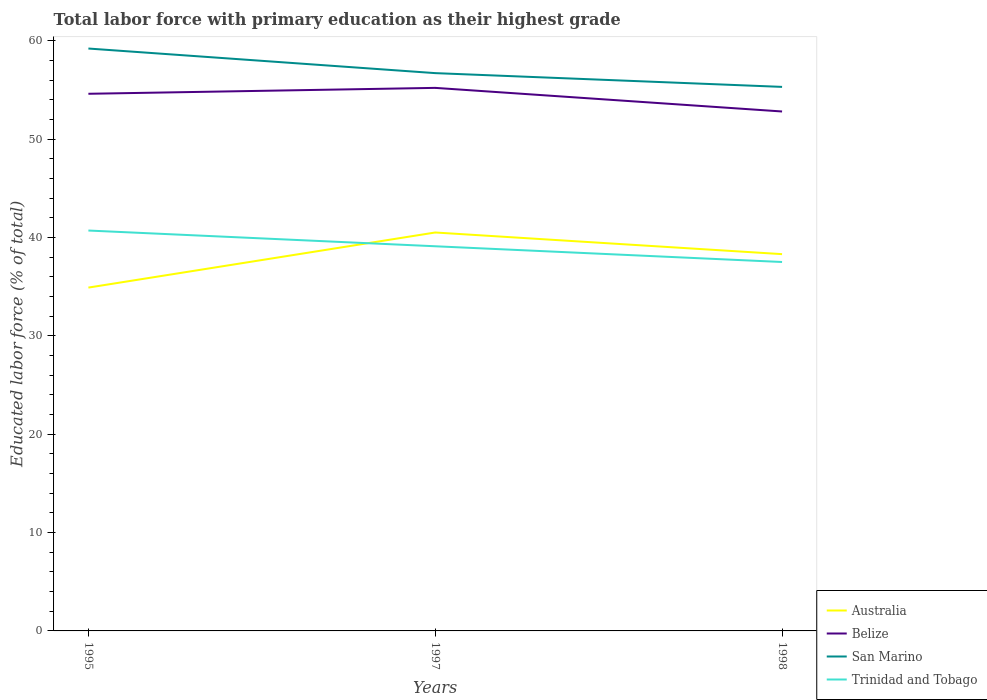Does the line corresponding to San Marino intersect with the line corresponding to Australia?
Provide a short and direct response. No. Across all years, what is the maximum percentage of total labor force with primary education in Trinidad and Tobago?
Offer a terse response. 37.5. What is the total percentage of total labor force with primary education in San Marino in the graph?
Your response must be concise. 1.4. What is the difference between the highest and the second highest percentage of total labor force with primary education in San Marino?
Keep it short and to the point. 3.9. What is the difference between the highest and the lowest percentage of total labor force with primary education in Belize?
Offer a very short reply. 2. How many years are there in the graph?
Keep it short and to the point. 3. What is the difference between two consecutive major ticks on the Y-axis?
Ensure brevity in your answer.  10. Does the graph contain grids?
Your response must be concise. No. Where does the legend appear in the graph?
Provide a short and direct response. Bottom right. How are the legend labels stacked?
Your answer should be compact. Vertical. What is the title of the graph?
Provide a succinct answer. Total labor force with primary education as their highest grade. Does "Romania" appear as one of the legend labels in the graph?
Provide a succinct answer. No. What is the label or title of the Y-axis?
Make the answer very short. Educated labor force (% of total). What is the Educated labor force (% of total) in Australia in 1995?
Provide a succinct answer. 34.9. What is the Educated labor force (% of total) of Belize in 1995?
Offer a terse response. 54.6. What is the Educated labor force (% of total) of San Marino in 1995?
Your answer should be compact. 59.2. What is the Educated labor force (% of total) in Trinidad and Tobago in 1995?
Keep it short and to the point. 40.7. What is the Educated labor force (% of total) in Australia in 1997?
Keep it short and to the point. 40.5. What is the Educated labor force (% of total) of Belize in 1997?
Provide a succinct answer. 55.2. What is the Educated labor force (% of total) in San Marino in 1997?
Make the answer very short. 56.7. What is the Educated labor force (% of total) in Trinidad and Tobago in 1997?
Offer a terse response. 39.1. What is the Educated labor force (% of total) of Australia in 1998?
Offer a terse response. 38.3. What is the Educated labor force (% of total) of Belize in 1998?
Ensure brevity in your answer.  52.8. What is the Educated labor force (% of total) in San Marino in 1998?
Offer a terse response. 55.3. What is the Educated labor force (% of total) of Trinidad and Tobago in 1998?
Offer a very short reply. 37.5. Across all years, what is the maximum Educated labor force (% of total) in Australia?
Ensure brevity in your answer.  40.5. Across all years, what is the maximum Educated labor force (% of total) in Belize?
Give a very brief answer. 55.2. Across all years, what is the maximum Educated labor force (% of total) in San Marino?
Give a very brief answer. 59.2. Across all years, what is the maximum Educated labor force (% of total) of Trinidad and Tobago?
Offer a very short reply. 40.7. Across all years, what is the minimum Educated labor force (% of total) in Australia?
Provide a short and direct response. 34.9. Across all years, what is the minimum Educated labor force (% of total) in Belize?
Make the answer very short. 52.8. Across all years, what is the minimum Educated labor force (% of total) in San Marino?
Provide a short and direct response. 55.3. Across all years, what is the minimum Educated labor force (% of total) in Trinidad and Tobago?
Keep it short and to the point. 37.5. What is the total Educated labor force (% of total) in Australia in the graph?
Make the answer very short. 113.7. What is the total Educated labor force (% of total) in Belize in the graph?
Your response must be concise. 162.6. What is the total Educated labor force (% of total) of San Marino in the graph?
Your answer should be very brief. 171.2. What is the total Educated labor force (% of total) in Trinidad and Tobago in the graph?
Provide a succinct answer. 117.3. What is the difference between the Educated labor force (% of total) in Belize in 1995 and that in 1997?
Offer a terse response. -0.6. What is the difference between the Educated labor force (% of total) of San Marino in 1995 and that in 1997?
Your answer should be compact. 2.5. What is the difference between the Educated labor force (% of total) in Australia in 1995 and that in 1998?
Provide a succinct answer. -3.4. What is the difference between the Educated labor force (% of total) of Belize in 1995 and that in 1998?
Your answer should be compact. 1.8. What is the difference between the Educated labor force (% of total) of Trinidad and Tobago in 1995 and that in 1998?
Make the answer very short. 3.2. What is the difference between the Educated labor force (% of total) in Australia in 1997 and that in 1998?
Give a very brief answer. 2.2. What is the difference between the Educated labor force (% of total) in San Marino in 1997 and that in 1998?
Make the answer very short. 1.4. What is the difference between the Educated labor force (% of total) of Trinidad and Tobago in 1997 and that in 1998?
Keep it short and to the point. 1.6. What is the difference between the Educated labor force (% of total) of Australia in 1995 and the Educated labor force (% of total) of Belize in 1997?
Provide a succinct answer. -20.3. What is the difference between the Educated labor force (% of total) in Australia in 1995 and the Educated labor force (% of total) in San Marino in 1997?
Your response must be concise. -21.8. What is the difference between the Educated labor force (% of total) of Australia in 1995 and the Educated labor force (% of total) of Trinidad and Tobago in 1997?
Give a very brief answer. -4.2. What is the difference between the Educated labor force (% of total) of Belize in 1995 and the Educated labor force (% of total) of Trinidad and Tobago in 1997?
Your response must be concise. 15.5. What is the difference between the Educated labor force (% of total) in San Marino in 1995 and the Educated labor force (% of total) in Trinidad and Tobago in 1997?
Provide a short and direct response. 20.1. What is the difference between the Educated labor force (% of total) in Australia in 1995 and the Educated labor force (% of total) in Belize in 1998?
Offer a terse response. -17.9. What is the difference between the Educated labor force (% of total) of Australia in 1995 and the Educated labor force (% of total) of San Marino in 1998?
Provide a succinct answer. -20.4. What is the difference between the Educated labor force (% of total) in Australia in 1995 and the Educated labor force (% of total) in Trinidad and Tobago in 1998?
Keep it short and to the point. -2.6. What is the difference between the Educated labor force (% of total) of San Marino in 1995 and the Educated labor force (% of total) of Trinidad and Tobago in 1998?
Provide a succinct answer. 21.7. What is the difference between the Educated labor force (% of total) in Australia in 1997 and the Educated labor force (% of total) in Belize in 1998?
Give a very brief answer. -12.3. What is the difference between the Educated labor force (% of total) in Australia in 1997 and the Educated labor force (% of total) in San Marino in 1998?
Give a very brief answer. -14.8. What is the average Educated labor force (% of total) of Australia per year?
Your answer should be very brief. 37.9. What is the average Educated labor force (% of total) in Belize per year?
Offer a very short reply. 54.2. What is the average Educated labor force (% of total) in San Marino per year?
Ensure brevity in your answer.  57.07. What is the average Educated labor force (% of total) in Trinidad and Tobago per year?
Ensure brevity in your answer.  39.1. In the year 1995, what is the difference between the Educated labor force (% of total) in Australia and Educated labor force (% of total) in Belize?
Offer a very short reply. -19.7. In the year 1995, what is the difference between the Educated labor force (% of total) of Australia and Educated labor force (% of total) of San Marino?
Ensure brevity in your answer.  -24.3. In the year 1995, what is the difference between the Educated labor force (% of total) of Australia and Educated labor force (% of total) of Trinidad and Tobago?
Your answer should be compact. -5.8. In the year 1997, what is the difference between the Educated labor force (% of total) of Australia and Educated labor force (% of total) of Belize?
Ensure brevity in your answer.  -14.7. In the year 1997, what is the difference between the Educated labor force (% of total) in Australia and Educated labor force (% of total) in San Marino?
Keep it short and to the point. -16.2. In the year 1997, what is the difference between the Educated labor force (% of total) of Australia and Educated labor force (% of total) of Trinidad and Tobago?
Offer a terse response. 1.4. In the year 1997, what is the difference between the Educated labor force (% of total) of Belize and Educated labor force (% of total) of San Marino?
Make the answer very short. -1.5. In the year 1997, what is the difference between the Educated labor force (% of total) of Belize and Educated labor force (% of total) of Trinidad and Tobago?
Offer a very short reply. 16.1. In the year 1997, what is the difference between the Educated labor force (% of total) of San Marino and Educated labor force (% of total) of Trinidad and Tobago?
Your answer should be very brief. 17.6. In the year 1998, what is the difference between the Educated labor force (% of total) in Australia and Educated labor force (% of total) in Belize?
Your answer should be very brief. -14.5. In the year 1998, what is the difference between the Educated labor force (% of total) of Australia and Educated labor force (% of total) of Trinidad and Tobago?
Offer a terse response. 0.8. In the year 1998, what is the difference between the Educated labor force (% of total) in Belize and Educated labor force (% of total) in San Marino?
Offer a very short reply. -2.5. In the year 1998, what is the difference between the Educated labor force (% of total) of Belize and Educated labor force (% of total) of Trinidad and Tobago?
Ensure brevity in your answer.  15.3. What is the ratio of the Educated labor force (% of total) in Australia in 1995 to that in 1997?
Make the answer very short. 0.86. What is the ratio of the Educated labor force (% of total) in San Marino in 1995 to that in 1997?
Provide a short and direct response. 1.04. What is the ratio of the Educated labor force (% of total) in Trinidad and Tobago in 1995 to that in 1997?
Ensure brevity in your answer.  1.04. What is the ratio of the Educated labor force (% of total) in Australia in 1995 to that in 1998?
Offer a terse response. 0.91. What is the ratio of the Educated labor force (% of total) of Belize in 1995 to that in 1998?
Provide a short and direct response. 1.03. What is the ratio of the Educated labor force (% of total) of San Marino in 1995 to that in 1998?
Your answer should be very brief. 1.07. What is the ratio of the Educated labor force (% of total) of Trinidad and Tobago in 1995 to that in 1998?
Provide a short and direct response. 1.09. What is the ratio of the Educated labor force (% of total) of Australia in 1997 to that in 1998?
Offer a terse response. 1.06. What is the ratio of the Educated labor force (% of total) of Belize in 1997 to that in 1998?
Your answer should be compact. 1.05. What is the ratio of the Educated labor force (% of total) in San Marino in 1997 to that in 1998?
Keep it short and to the point. 1.03. What is the ratio of the Educated labor force (% of total) in Trinidad and Tobago in 1997 to that in 1998?
Provide a succinct answer. 1.04. What is the difference between the highest and the second highest Educated labor force (% of total) in Australia?
Give a very brief answer. 2.2. What is the difference between the highest and the second highest Educated labor force (% of total) of Belize?
Offer a terse response. 0.6. What is the difference between the highest and the second highest Educated labor force (% of total) of Trinidad and Tobago?
Provide a succinct answer. 1.6. What is the difference between the highest and the lowest Educated labor force (% of total) of Australia?
Give a very brief answer. 5.6. What is the difference between the highest and the lowest Educated labor force (% of total) in Belize?
Provide a short and direct response. 2.4. What is the difference between the highest and the lowest Educated labor force (% of total) in San Marino?
Ensure brevity in your answer.  3.9. 